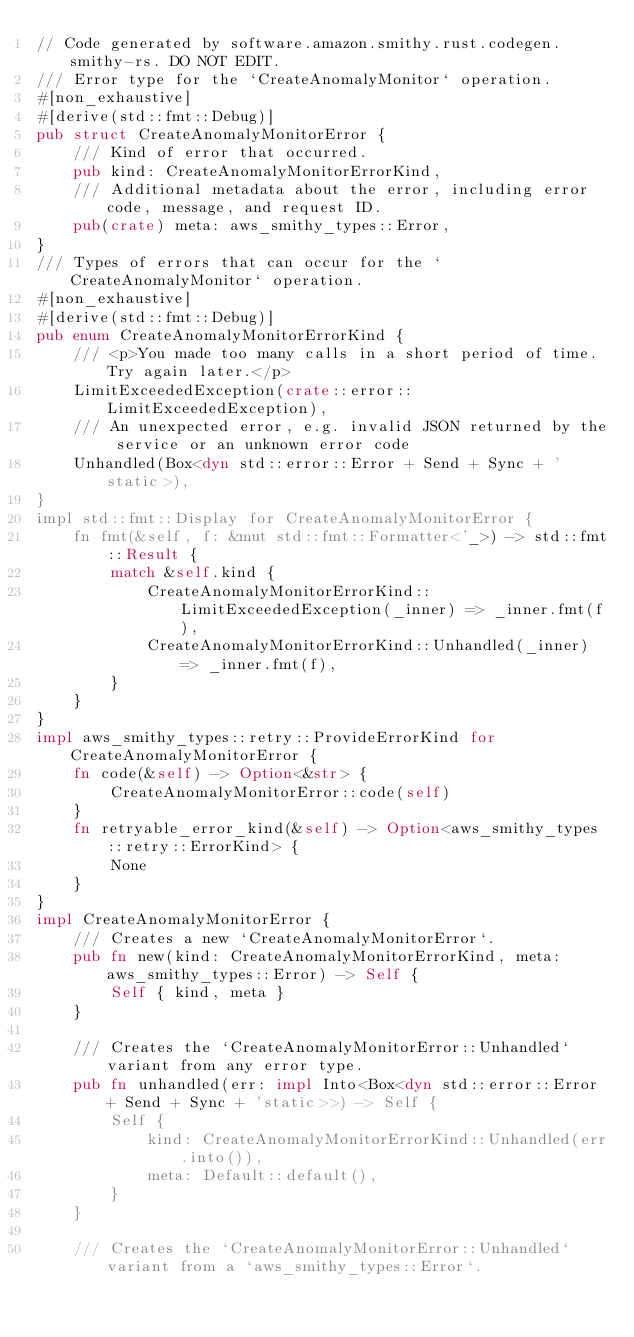<code> <loc_0><loc_0><loc_500><loc_500><_Rust_>// Code generated by software.amazon.smithy.rust.codegen.smithy-rs. DO NOT EDIT.
/// Error type for the `CreateAnomalyMonitor` operation.
#[non_exhaustive]
#[derive(std::fmt::Debug)]
pub struct CreateAnomalyMonitorError {
    /// Kind of error that occurred.
    pub kind: CreateAnomalyMonitorErrorKind,
    /// Additional metadata about the error, including error code, message, and request ID.
    pub(crate) meta: aws_smithy_types::Error,
}
/// Types of errors that can occur for the `CreateAnomalyMonitor` operation.
#[non_exhaustive]
#[derive(std::fmt::Debug)]
pub enum CreateAnomalyMonitorErrorKind {
    /// <p>You made too many calls in a short period of time. Try again later.</p>
    LimitExceededException(crate::error::LimitExceededException),
    /// An unexpected error, e.g. invalid JSON returned by the service or an unknown error code
    Unhandled(Box<dyn std::error::Error + Send + Sync + 'static>),
}
impl std::fmt::Display for CreateAnomalyMonitorError {
    fn fmt(&self, f: &mut std::fmt::Formatter<'_>) -> std::fmt::Result {
        match &self.kind {
            CreateAnomalyMonitorErrorKind::LimitExceededException(_inner) => _inner.fmt(f),
            CreateAnomalyMonitorErrorKind::Unhandled(_inner) => _inner.fmt(f),
        }
    }
}
impl aws_smithy_types::retry::ProvideErrorKind for CreateAnomalyMonitorError {
    fn code(&self) -> Option<&str> {
        CreateAnomalyMonitorError::code(self)
    }
    fn retryable_error_kind(&self) -> Option<aws_smithy_types::retry::ErrorKind> {
        None
    }
}
impl CreateAnomalyMonitorError {
    /// Creates a new `CreateAnomalyMonitorError`.
    pub fn new(kind: CreateAnomalyMonitorErrorKind, meta: aws_smithy_types::Error) -> Self {
        Self { kind, meta }
    }

    /// Creates the `CreateAnomalyMonitorError::Unhandled` variant from any error type.
    pub fn unhandled(err: impl Into<Box<dyn std::error::Error + Send + Sync + 'static>>) -> Self {
        Self {
            kind: CreateAnomalyMonitorErrorKind::Unhandled(err.into()),
            meta: Default::default(),
        }
    }

    /// Creates the `CreateAnomalyMonitorError::Unhandled` variant from a `aws_smithy_types::Error`.</code> 